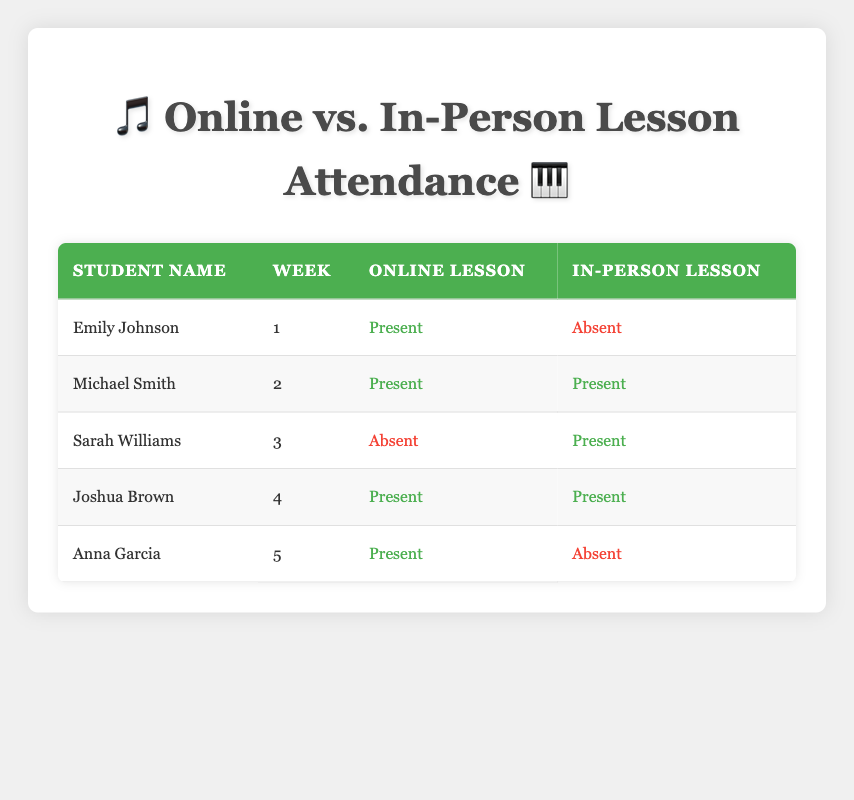What lesson type did Emily Johnson attend in Week 1? According to the table, Emily Johnson's attendance in Week 1 for Online lesson was "Present" and for In-Person lesson was "Absent." Therefore, she attended the Online lesson.
Answer: Online How many students attended In-Person lessons in Week 2? The table shows that Michael Smith was the only student who attended In-Person lessons in Week 2, marked as "Present." Therefore, one student attended.
Answer: 1 Did Sarah Williams attend Online lessons in Week 3? In the table, it indicates that Sarah Williams was marked as "Absent" for Online lessons in Week 3. Therefore, she did not attend Online lessons.
Answer: No What is the total number of Present attendance records for Online lessons? By reviewing the table, the entries for Online lessons marked as "Present" are for Emily Johnson (Week 1), Michael Smith (Week 2), Joshua Brown (Week 4), and Anna Garcia (Week 5). That's a total of 4 present attendances.
Answer: 4 Which student had a contrasting attendance in Online and In-Person lessons during Week 5? Looking at Week 5 in the table, Anna Garcia was "Present" for Online lessons and "Absent" for In-Person lessons, which is the contrasting attendance.
Answer: Anna Garcia In total, how many lessons did Michael Smith attend across both formats during Week 2? Referring to the table, Michael Smith was marked as "Present" for both Online and In-Person lessons in Week 2. This means he attended 2 lessons in total.
Answer: 2 Was there any student who attended both types of lessons in Week 4? The table shows Joshua Brown attended both types of lessons in Week 4 with "Present" for both Online and In-Person lessons. Thus, there was at least one student who attended both types.
Answer: Yes What is the average attendance for In-Person lessons based on the table? There are 5 total records for In-Person attendance: 2 Present (Michael Smith and Joshua Brown) and 3 Absent (Emily Johnson, Sarah Williams, and Anna Garcia). The average attendance is 2 Present out of 5 records = 40%.
Answer: 40% 